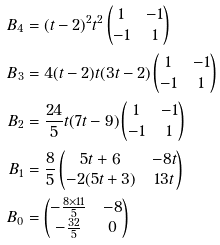Convert formula to latex. <formula><loc_0><loc_0><loc_500><loc_500>B _ { 4 } & = ( t - 2 ) ^ { 2 } t ^ { 2 } \begin{pmatrix} 1 & - 1 \\ - 1 & 1 \end{pmatrix} \\ B _ { 3 } & = 4 ( t - 2 ) t ( 3 t - 2 ) \begin{pmatrix} 1 & - 1 \\ - 1 & 1 \end{pmatrix} \\ B _ { 2 } & = \frac { 2 4 } { 5 } t ( 7 t - 9 ) \begin{pmatrix} 1 & - 1 \\ - 1 & 1 \end{pmatrix} \\ B _ { 1 } & = \frac { 8 } { 5 } \begin{pmatrix} 5 t + 6 & - 8 t \\ - 2 ( 5 t + 3 ) & 1 3 t \end{pmatrix} \\ B _ { 0 } & = \begin{pmatrix} - \frac { 8 \times 1 1 } { 5 } & - 8 \\ - \frac { 3 2 } { 5 } & 0 \end{pmatrix}</formula> 